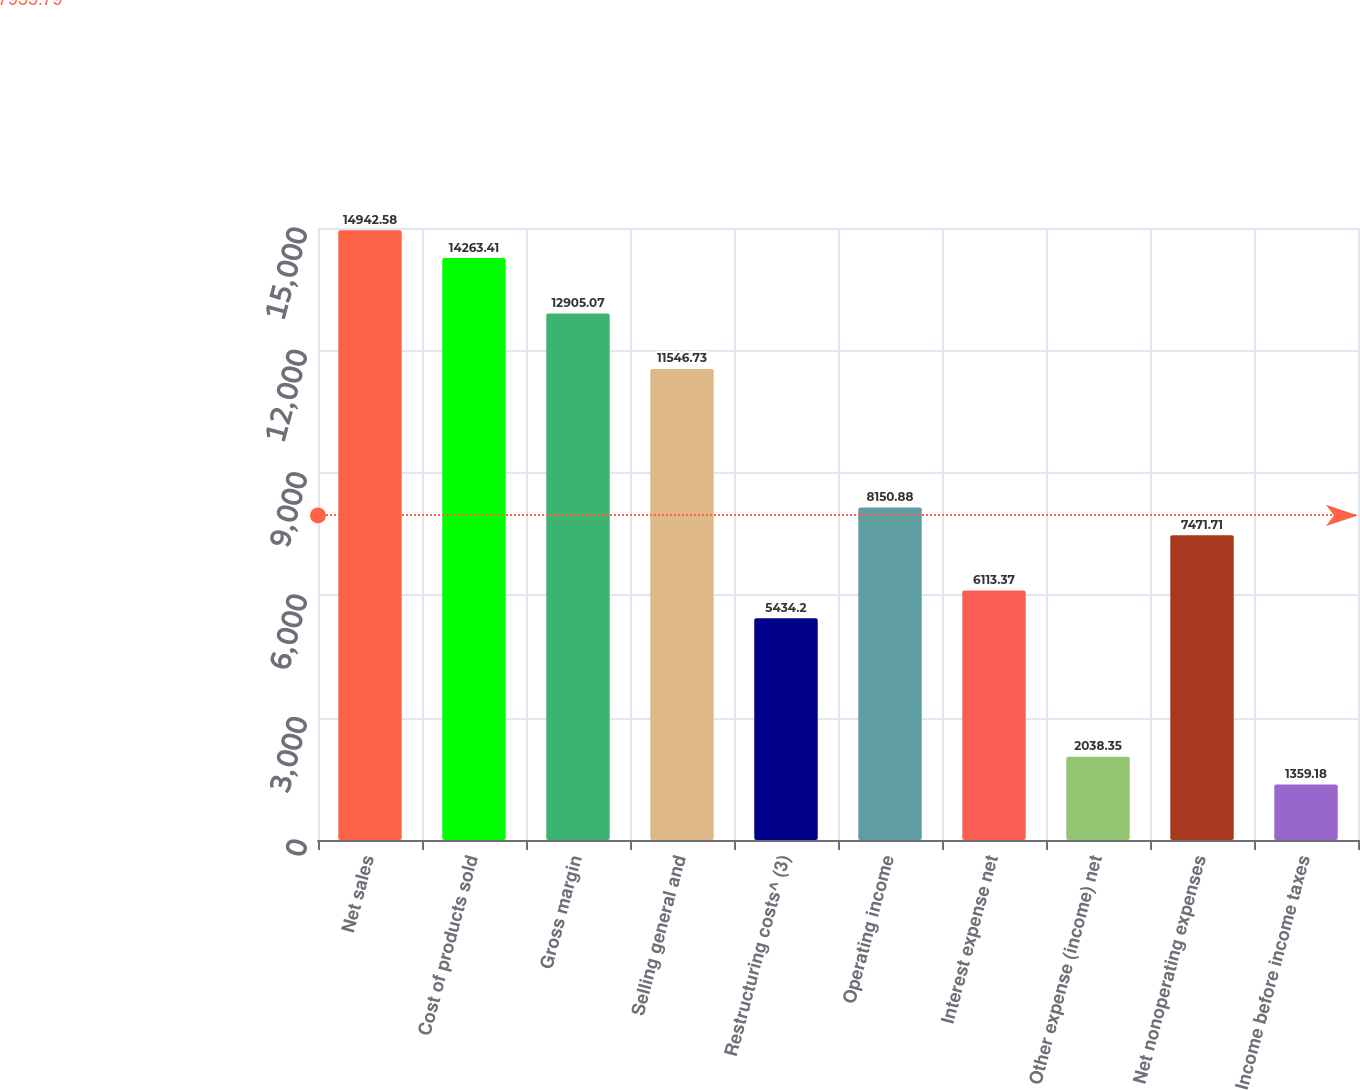<chart> <loc_0><loc_0><loc_500><loc_500><bar_chart><fcel>Net sales<fcel>Cost of products sold<fcel>Gross margin<fcel>Selling general and<fcel>Restructuring costs^ (3)<fcel>Operating income<fcel>Interest expense net<fcel>Other expense (income) net<fcel>Net nonoperating expenses<fcel>Income before income taxes<nl><fcel>14942.6<fcel>14263.4<fcel>12905.1<fcel>11546.7<fcel>5434.2<fcel>8150.88<fcel>6113.37<fcel>2038.35<fcel>7471.71<fcel>1359.18<nl></chart> 